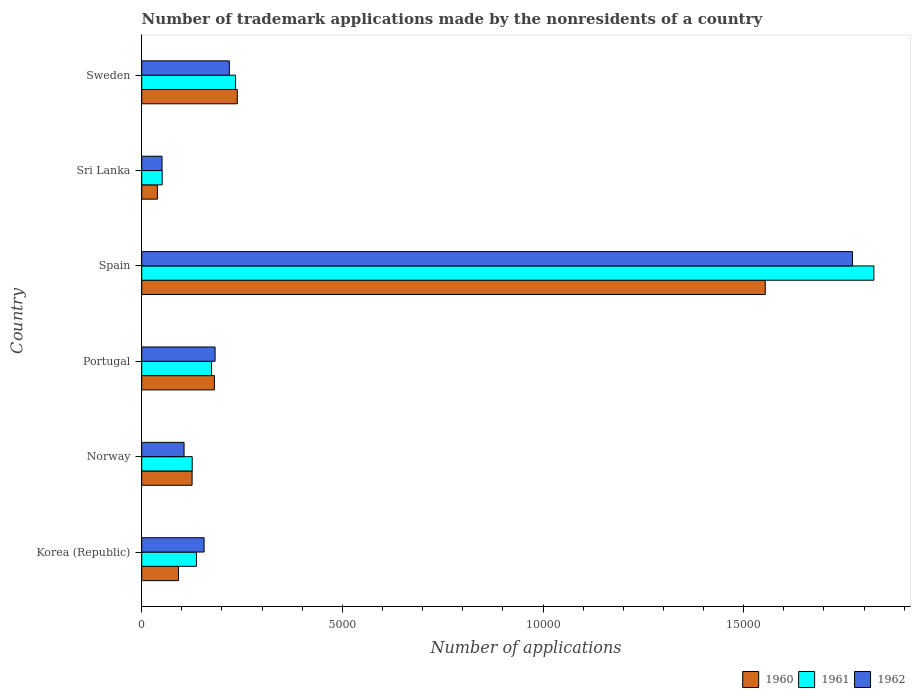How many different coloured bars are there?
Keep it short and to the point. 3. How many groups of bars are there?
Your response must be concise. 6. Are the number of bars per tick equal to the number of legend labels?
Provide a short and direct response. Yes. How many bars are there on the 6th tick from the top?
Keep it short and to the point. 3. How many bars are there on the 6th tick from the bottom?
Your answer should be compact. 3. What is the number of trademark applications made by the nonresidents in 1961 in Spain?
Your response must be concise. 1.82e+04. Across all countries, what is the maximum number of trademark applications made by the nonresidents in 1961?
Make the answer very short. 1.82e+04. Across all countries, what is the minimum number of trademark applications made by the nonresidents in 1960?
Your response must be concise. 391. In which country was the number of trademark applications made by the nonresidents in 1960 maximum?
Your answer should be compact. Spain. In which country was the number of trademark applications made by the nonresidents in 1960 minimum?
Make the answer very short. Sri Lanka. What is the total number of trademark applications made by the nonresidents in 1962 in the graph?
Your answer should be compact. 2.48e+04. What is the difference between the number of trademark applications made by the nonresidents in 1960 in Korea (Republic) and that in Spain?
Your response must be concise. -1.46e+04. What is the difference between the number of trademark applications made by the nonresidents in 1960 in Portugal and the number of trademark applications made by the nonresidents in 1961 in Sweden?
Your answer should be compact. -527. What is the average number of trademark applications made by the nonresidents in 1962 per country?
Offer a very short reply. 4139.33. What is the difference between the number of trademark applications made by the nonresidents in 1961 and number of trademark applications made by the nonresidents in 1962 in Spain?
Provide a succinct answer. 534. What is the ratio of the number of trademark applications made by the nonresidents in 1960 in Korea (Republic) to that in Sweden?
Provide a short and direct response. 0.38. Is the number of trademark applications made by the nonresidents in 1962 in Spain less than that in Sri Lanka?
Your answer should be compact. No. What is the difference between the highest and the second highest number of trademark applications made by the nonresidents in 1960?
Keep it short and to the point. 1.32e+04. What is the difference between the highest and the lowest number of trademark applications made by the nonresidents in 1960?
Give a very brief answer. 1.51e+04. What does the 2nd bar from the bottom in Spain represents?
Provide a succinct answer. 1961. Does the graph contain grids?
Offer a terse response. No. How are the legend labels stacked?
Your answer should be very brief. Horizontal. What is the title of the graph?
Provide a short and direct response. Number of trademark applications made by the nonresidents of a country. Does "2013" appear as one of the legend labels in the graph?
Keep it short and to the point. No. What is the label or title of the X-axis?
Provide a short and direct response. Number of applications. What is the label or title of the Y-axis?
Make the answer very short. Country. What is the Number of applications of 1960 in Korea (Republic)?
Give a very brief answer. 916. What is the Number of applications of 1961 in Korea (Republic)?
Your response must be concise. 1363. What is the Number of applications in 1962 in Korea (Republic)?
Your answer should be very brief. 1554. What is the Number of applications in 1960 in Norway?
Keep it short and to the point. 1255. What is the Number of applications of 1961 in Norway?
Make the answer very short. 1258. What is the Number of applications of 1962 in Norway?
Make the answer very short. 1055. What is the Number of applications of 1960 in Portugal?
Provide a short and direct response. 1811. What is the Number of applications of 1961 in Portugal?
Provide a short and direct response. 1740. What is the Number of applications of 1962 in Portugal?
Keep it short and to the point. 1828. What is the Number of applications in 1960 in Spain?
Make the answer very short. 1.55e+04. What is the Number of applications in 1961 in Spain?
Provide a succinct answer. 1.82e+04. What is the Number of applications in 1962 in Spain?
Your answer should be compact. 1.77e+04. What is the Number of applications in 1960 in Sri Lanka?
Provide a succinct answer. 391. What is the Number of applications in 1961 in Sri Lanka?
Keep it short and to the point. 510. What is the Number of applications of 1962 in Sri Lanka?
Give a very brief answer. 506. What is the Number of applications in 1960 in Sweden?
Give a very brief answer. 2381. What is the Number of applications in 1961 in Sweden?
Offer a very short reply. 2338. What is the Number of applications of 1962 in Sweden?
Give a very brief answer. 2183. Across all countries, what is the maximum Number of applications of 1960?
Ensure brevity in your answer.  1.55e+04. Across all countries, what is the maximum Number of applications in 1961?
Keep it short and to the point. 1.82e+04. Across all countries, what is the maximum Number of applications in 1962?
Give a very brief answer. 1.77e+04. Across all countries, what is the minimum Number of applications in 1960?
Your response must be concise. 391. Across all countries, what is the minimum Number of applications in 1961?
Offer a terse response. 510. Across all countries, what is the minimum Number of applications of 1962?
Give a very brief answer. 506. What is the total Number of applications in 1960 in the graph?
Your answer should be very brief. 2.23e+04. What is the total Number of applications in 1961 in the graph?
Your answer should be compact. 2.55e+04. What is the total Number of applications in 1962 in the graph?
Your answer should be compact. 2.48e+04. What is the difference between the Number of applications in 1960 in Korea (Republic) and that in Norway?
Provide a short and direct response. -339. What is the difference between the Number of applications of 1961 in Korea (Republic) and that in Norway?
Make the answer very short. 105. What is the difference between the Number of applications of 1962 in Korea (Republic) and that in Norway?
Keep it short and to the point. 499. What is the difference between the Number of applications of 1960 in Korea (Republic) and that in Portugal?
Your response must be concise. -895. What is the difference between the Number of applications in 1961 in Korea (Republic) and that in Portugal?
Your response must be concise. -377. What is the difference between the Number of applications of 1962 in Korea (Republic) and that in Portugal?
Your response must be concise. -274. What is the difference between the Number of applications in 1960 in Korea (Republic) and that in Spain?
Your response must be concise. -1.46e+04. What is the difference between the Number of applications of 1961 in Korea (Republic) and that in Spain?
Provide a succinct answer. -1.69e+04. What is the difference between the Number of applications in 1962 in Korea (Republic) and that in Spain?
Give a very brief answer. -1.62e+04. What is the difference between the Number of applications in 1960 in Korea (Republic) and that in Sri Lanka?
Make the answer very short. 525. What is the difference between the Number of applications of 1961 in Korea (Republic) and that in Sri Lanka?
Keep it short and to the point. 853. What is the difference between the Number of applications of 1962 in Korea (Republic) and that in Sri Lanka?
Your answer should be compact. 1048. What is the difference between the Number of applications in 1960 in Korea (Republic) and that in Sweden?
Offer a terse response. -1465. What is the difference between the Number of applications of 1961 in Korea (Republic) and that in Sweden?
Give a very brief answer. -975. What is the difference between the Number of applications of 1962 in Korea (Republic) and that in Sweden?
Your answer should be very brief. -629. What is the difference between the Number of applications in 1960 in Norway and that in Portugal?
Offer a terse response. -556. What is the difference between the Number of applications in 1961 in Norway and that in Portugal?
Offer a terse response. -482. What is the difference between the Number of applications of 1962 in Norway and that in Portugal?
Provide a short and direct response. -773. What is the difference between the Number of applications of 1960 in Norway and that in Spain?
Your response must be concise. -1.43e+04. What is the difference between the Number of applications of 1961 in Norway and that in Spain?
Your answer should be compact. -1.70e+04. What is the difference between the Number of applications of 1962 in Norway and that in Spain?
Keep it short and to the point. -1.67e+04. What is the difference between the Number of applications in 1960 in Norway and that in Sri Lanka?
Keep it short and to the point. 864. What is the difference between the Number of applications of 1961 in Norway and that in Sri Lanka?
Provide a short and direct response. 748. What is the difference between the Number of applications of 1962 in Norway and that in Sri Lanka?
Offer a very short reply. 549. What is the difference between the Number of applications of 1960 in Norway and that in Sweden?
Provide a short and direct response. -1126. What is the difference between the Number of applications in 1961 in Norway and that in Sweden?
Offer a very short reply. -1080. What is the difference between the Number of applications in 1962 in Norway and that in Sweden?
Provide a succinct answer. -1128. What is the difference between the Number of applications in 1960 in Portugal and that in Spain?
Provide a short and direct response. -1.37e+04. What is the difference between the Number of applications of 1961 in Portugal and that in Spain?
Keep it short and to the point. -1.65e+04. What is the difference between the Number of applications in 1962 in Portugal and that in Spain?
Provide a short and direct response. -1.59e+04. What is the difference between the Number of applications in 1960 in Portugal and that in Sri Lanka?
Your answer should be very brief. 1420. What is the difference between the Number of applications of 1961 in Portugal and that in Sri Lanka?
Make the answer very short. 1230. What is the difference between the Number of applications in 1962 in Portugal and that in Sri Lanka?
Make the answer very short. 1322. What is the difference between the Number of applications in 1960 in Portugal and that in Sweden?
Your response must be concise. -570. What is the difference between the Number of applications in 1961 in Portugal and that in Sweden?
Keep it short and to the point. -598. What is the difference between the Number of applications of 1962 in Portugal and that in Sweden?
Your response must be concise. -355. What is the difference between the Number of applications in 1960 in Spain and that in Sri Lanka?
Ensure brevity in your answer.  1.51e+04. What is the difference between the Number of applications of 1961 in Spain and that in Sri Lanka?
Your answer should be very brief. 1.77e+04. What is the difference between the Number of applications of 1962 in Spain and that in Sri Lanka?
Ensure brevity in your answer.  1.72e+04. What is the difference between the Number of applications in 1960 in Spain and that in Sweden?
Provide a short and direct response. 1.32e+04. What is the difference between the Number of applications in 1961 in Spain and that in Sweden?
Ensure brevity in your answer.  1.59e+04. What is the difference between the Number of applications in 1962 in Spain and that in Sweden?
Your response must be concise. 1.55e+04. What is the difference between the Number of applications of 1960 in Sri Lanka and that in Sweden?
Offer a terse response. -1990. What is the difference between the Number of applications in 1961 in Sri Lanka and that in Sweden?
Offer a very short reply. -1828. What is the difference between the Number of applications in 1962 in Sri Lanka and that in Sweden?
Make the answer very short. -1677. What is the difference between the Number of applications in 1960 in Korea (Republic) and the Number of applications in 1961 in Norway?
Keep it short and to the point. -342. What is the difference between the Number of applications in 1960 in Korea (Republic) and the Number of applications in 1962 in Norway?
Your response must be concise. -139. What is the difference between the Number of applications of 1961 in Korea (Republic) and the Number of applications of 1962 in Norway?
Your response must be concise. 308. What is the difference between the Number of applications in 1960 in Korea (Republic) and the Number of applications in 1961 in Portugal?
Keep it short and to the point. -824. What is the difference between the Number of applications of 1960 in Korea (Republic) and the Number of applications of 1962 in Portugal?
Give a very brief answer. -912. What is the difference between the Number of applications in 1961 in Korea (Republic) and the Number of applications in 1962 in Portugal?
Offer a very short reply. -465. What is the difference between the Number of applications of 1960 in Korea (Republic) and the Number of applications of 1961 in Spain?
Offer a very short reply. -1.73e+04. What is the difference between the Number of applications in 1960 in Korea (Republic) and the Number of applications in 1962 in Spain?
Your response must be concise. -1.68e+04. What is the difference between the Number of applications of 1961 in Korea (Republic) and the Number of applications of 1962 in Spain?
Your response must be concise. -1.63e+04. What is the difference between the Number of applications of 1960 in Korea (Republic) and the Number of applications of 1961 in Sri Lanka?
Make the answer very short. 406. What is the difference between the Number of applications of 1960 in Korea (Republic) and the Number of applications of 1962 in Sri Lanka?
Provide a short and direct response. 410. What is the difference between the Number of applications of 1961 in Korea (Republic) and the Number of applications of 1962 in Sri Lanka?
Keep it short and to the point. 857. What is the difference between the Number of applications in 1960 in Korea (Republic) and the Number of applications in 1961 in Sweden?
Provide a short and direct response. -1422. What is the difference between the Number of applications in 1960 in Korea (Republic) and the Number of applications in 1962 in Sweden?
Ensure brevity in your answer.  -1267. What is the difference between the Number of applications of 1961 in Korea (Republic) and the Number of applications of 1962 in Sweden?
Your response must be concise. -820. What is the difference between the Number of applications of 1960 in Norway and the Number of applications of 1961 in Portugal?
Offer a terse response. -485. What is the difference between the Number of applications of 1960 in Norway and the Number of applications of 1962 in Portugal?
Your answer should be very brief. -573. What is the difference between the Number of applications of 1961 in Norway and the Number of applications of 1962 in Portugal?
Provide a short and direct response. -570. What is the difference between the Number of applications of 1960 in Norway and the Number of applications of 1961 in Spain?
Provide a succinct answer. -1.70e+04. What is the difference between the Number of applications in 1960 in Norway and the Number of applications in 1962 in Spain?
Your answer should be compact. -1.65e+04. What is the difference between the Number of applications in 1961 in Norway and the Number of applications in 1962 in Spain?
Ensure brevity in your answer.  -1.65e+04. What is the difference between the Number of applications in 1960 in Norway and the Number of applications in 1961 in Sri Lanka?
Make the answer very short. 745. What is the difference between the Number of applications in 1960 in Norway and the Number of applications in 1962 in Sri Lanka?
Your answer should be very brief. 749. What is the difference between the Number of applications in 1961 in Norway and the Number of applications in 1962 in Sri Lanka?
Your answer should be compact. 752. What is the difference between the Number of applications in 1960 in Norway and the Number of applications in 1961 in Sweden?
Provide a short and direct response. -1083. What is the difference between the Number of applications of 1960 in Norway and the Number of applications of 1962 in Sweden?
Your response must be concise. -928. What is the difference between the Number of applications in 1961 in Norway and the Number of applications in 1962 in Sweden?
Your response must be concise. -925. What is the difference between the Number of applications in 1960 in Portugal and the Number of applications in 1961 in Spain?
Provide a succinct answer. -1.64e+04. What is the difference between the Number of applications of 1960 in Portugal and the Number of applications of 1962 in Spain?
Give a very brief answer. -1.59e+04. What is the difference between the Number of applications of 1961 in Portugal and the Number of applications of 1962 in Spain?
Offer a terse response. -1.60e+04. What is the difference between the Number of applications in 1960 in Portugal and the Number of applications in 1961 in Sri Lanka?
Ensure brevity in your answer.  1301. What is the difference between the Number of applications in 1960 in Portugal and the Number of applications in 1962 in Sri Lanka?
Provide a succinct answer. 1305. What is the difference between the Number of applications of 1961 in Portugal and the Number of applications of 1962 in Sri Lanka?
Ensure brevity in your answer.  1234. What is the difference between the Number of applications of 1960 in Portugal and the Number of applications of 1961 in Sweden?
Offer a terse response. -527. What is the difference between the Number of applications of 1960 in Portugal and the Number of applications of 1962 in Sweden?
Provide a succinct answer. -372. What is the difference between the Number of applications of 1961 in Portugal and the Number of applications of 1962 in Sweden?
Your response must be concise. -443. What is the difference between the Number of applications in 1960 in Spain and the Number of applications in 1961 in Sri Lanka?
Your answer should be compact. 1.50e+04. What is the difference between the Number of applications of 1960 in Spain and the Number of applications of 1962 in Sri Lanka?
Ensure brevity in your answer.  1.50e+04. What is the difference between the Number of applications of 1961 in Spain and the Number of applications of 1962 in Sri Lanka?
Give a very brief answer. 1.77e+04. What is the difference between the Number of applications of 1960 in Spain and the Number of applications of 1961 in Sweden?
Offer a terse response. 1.32e+04. What is the difference between the Number of applications in 1960 in Spain and the Number of applications in 1962 in Sweden?
Your answer should be very brief. 1.34e+04. What is the difference between the Number of applications in 1961 in Spain and the Number of applications in 1962 in Sweden?
Offer a terse response. 1.61e+04. What is the difference between the Number of applications in 1960 in Sri Lanka and the Number of applications in 1961 in Sweden?
Your response must be concise. -1947. What is the difference between the Number of applications of 1960 in Sri Lanka and the Number of applications of 1962 in Sweden?
Your response must be concise. -1792. What is the difference between the Number of applications of 1961 in Sri Lanka and the Number of applications of 1962 in Sweden?
Offer a terse response. -1673. What is the average Number of applications of 1960 per country?
Ensure brevity in your answer.  3715.17. What is the average Number of applications in 1961 per country?
Give a very brief answer. 4242.17. What is the average Number of applications in 1962 per country?
Offer a terse response. 4139.33. What is the difference between the Number of applications in 1960 and Number of applications in 1961 in Korea (Republic)?
Offer a terse response. -447. What is the difference between the Number of applications in 1960 and Number of applications in 1962 in Korea (Republic)?
Provide a short and direct response. -638. What is the difference between the Number of applications of 1961 and Number of applications of 1962 in Korea (Republic)?
Your answer should be compact. -191. What is the difference between the Number of applications of 1960 and Number of applications of 1961 in Norway?
Your response must be concise. -3. What is the difference between the Number of applications in 1960 and Number of applications in 1962 in Norway?
Provide a short and direct response. 200. What is the difference between the Number of applications in 1961 and Number of applications in 1962 in Norway?
Offer a very short reply. 203. What is the difference between the Number of applications in 1960 and Number of applications in 1961 in Portugal?
Your answer should be compact. 71. What is the difference between the Number of applications of 1960 and Number of applications of 1962 in Portugal?
Offer a terse response. -17. What is the difference between the Number of applications in 1961 and Number of applications in 1962 in Portugal?
Your answer should be compact. -88. What is the difference between the Number of applications in 1960 and Number of applications in 1961 in Spain?
Ensure brevity in your answer.  -2707. What is the difference between the Number of applications of 1960 and Number of applications of 1962 in Spain?
Give a very brief answer. -2173. What is the difference between the Number of applications in 1961 and Number of applications in 1962 in Spain?
Keep it short and to the point. 534. What is the difference between the Number of applications of 1960 and Number of applications of 1961 in Sri Lanka?
Provide a succinct answer. -119. What is the difference between the Number of applications of 1960 and Number of applications of 1962 in Sri Lanka?
Offer a terse response. -115. What is the difference between the Number of applications of 1961 and Number of applications of 1962 in Sri Lanka?
Your response must be concise. 4. What is the difference between the Number of applications of 1960 and Number of applications of 1961 in Sweden?
Provide a short and direct response. 43. What is the difference between the Number of applications in 1960 and Number of applications in 1962 in Sweden?
Your answer should be very brief. 198. What is the difference between the Number of applications in 1961 and Number of applications in 1962 in Sweden?
Keep it short and to the point. 155. What is the ratio of the Number of applications in 1960 in Korea (Republic) to that in Norway?
Make the answer very short. 0.73. What is the ratio of the Number of applications in 1961 in Korea (Republic) to that in Norway?
Give a very brief answer. 1.08. What is the ratio of the Number of applications of 1962 in Korea (Republic) to that in Norway?
Make the answer very short. 1.47. What is the ratio of the Number of applications of 1960 in Korea (Republic) to that in Portugal?
Give a very brief answer. 0.51. What is the ratio of the Number of applications in 1961 in Korea (Republic) to that in Portugal?
Offer a very short reply. 0.78. What is the ratio of the Number of applications in 1962 in Korea (Republic) to that in Portugal?
Your response must be concise. 0.85. What is the ratio of the Number of applications in 1960 in Korea (Republic) to that in Spain?
Provide a succinct answer. 0.06. What is the ratio of the Number of applications of 1961 in Korea (Republic) to that in Spain?
Keep it short and to the point. 0.07. What is the ratio of the Number of applications of 1962 in Korea (Republic) to that in Spain?
Ensure brevity in your answer.  0.09. What is the ratio of the Number of applications of 1960 in Korea (Republic) to that in Sri Lanka?
Keep it short and to the point. 2.34. What is the ratio of the Number of applications in 1961 in Korea (Republic) to that in Sri Lanka?
Your response must be concise. 2.67. What is the ratio of the Number of applications of 1962 in Korea (Republic) to that in Sri Lanka?
Keep it short and to the point. 3.07. What is the ratio of the Number of applications of 1960 in Korea (Republic) to that in Sweden?
Your answer should be compact. 0.38. What is the ratio of the Number of applications in 1961 in Korea (Republic) to that in Sweden?
Your response must be concise. 0.58. What is the ratio of the Number of applications of 1962 in Korea (Republic) to that in Sweden?
Make the answer very short. 0.71. What is the ratio of the Number of applications in 1960 in Norway to that in Portugal?
Your answer should be very brief. 0.69. What is the ratio of the Number of applications of 1961 in Norway to that in Portugal?
Your answer should be very brief. 0.72. What is the ratio of the Number of applications in 1962 in Norway to that in Portugal?
Your answer should be very brief. 0.58. What is the ratio of the Number of applications in 1960 in Norway to that in Spain?
Keep it short and to the point. 0.08. What is the ratio of the Number of applications of 1961 in Norway to that in Spain?
Provide a succinct answer. 0.07. What is the ratio of the Number of applications in 1962 in Norway to that in Spain?
Your answer should be very brief. 0.06. What is the ratio of the Number of applications in 1960 in Norway to that in Sri Lanka?
Ensure brevity in your answer.  3.21. What is the ratio of the Number of applications of 1961 in Norway to that in Sri Lanka?
Provide a succinct answer. 2.47. What is the ratio of the Number of applications in 1962 in Norway to that in Sri Lanka?
Give a very brief answer. 2.08. What is the ratio of the Number of applications in 1960 in Norway to that in Sweden?
Give a very brief answer. 0.53. What is the ratio of the Number of applications in 1961 in Norway to that in Sweden?
Give a very brief answer. 0.54. What is the ratio of the Number of applications in 1962 in Norway to that in Sweden?
Provide a short and direct response. 0.48. What is the ratio of the Number of applications in 1960 in Portugal to that in Spain?
Your answer should be very brief. 0.12. What is the ratio of the Number of applications in 1961 in Portugal to that in Spain?
Your response must be concise. 0.1. What is the ratio of the Number of applications in 1962 in Portugal to that in Spain?
Your answer should be very brief. 0.1. What is the ratio of the Number of applications of 1960 in Portugal to that in Sri Lanka?
Provide a short and direct response. 4.63. What is the ratio of the Number of applications in 1961 in Portugal to that in Sri Lanka?
Your response must be concise. 3.41. What is the ratio of the Number of applications in 1962 in Portugal to that in Sri Lanka?
Your answer should be very brief. 3.61. What is the ratio of the Number of applications in 1960 in Portugal to that in Sweden?
Offer a very short reply. 0.76. What is the ratio of the Number of applications in 1961 in Portugal to that in Sweden?
Provide a succinct answer. 0.74. What is the ratio of the Number of applications in 1962 in Portugal to that in Sweden?
Provide a short and direct response. 0.84. What is the ratio of the Number of applications in 1960 in Spain to that in Sri Lanka?
Make the answer very short. 39.74. What is the ratio of the Number of applications of 1961 in Spain to that in Sri Lanka?
Offer a terse response. 35.77. What is the ratio of the Number of applications in 1960 in Spain to that in Sweden?
Offer a very short reply. 6.53. What is the ratio of the Number of applications of 1961 in Spain to that in Sweden?
Offer a very short reply. 7.8. What is the ratio of the Number of applications of 1962 in Spain to that in Sweden?
Give a very brief answer. 8.11. What is the ratio of the Number of applications of 1960 in Sri Lanka to that in Sweden?
Keep it short and to the point. 0.16. What is the ratio of the Number of applications in 1961 in Sri Lanka to that in Sweden?
Your answer should be very brief. 0.22. What is the ratio of the Number of applications in 1962 in Sri Lanka to that in Sweden?
Offer a very short reply. 0.23. What is the difference between the highest and the second highest Number of applications in 1960?
Offer a very short reply. 1.32e+04. What is the difference between the highest and the second highest Number of applications of 1961?
Your response must be concise. 1.59e+04. What is the difference between the highest and the second highest Number of applications in 1962?
Ensure brevity in your answer.  1.55e+04. What is the difference between the highest and the lowest Number of applications in 1960?
Offer a terse response. 1.51e+04. What is the difference between the highest and the lowest Number of applications in 1961?
Offer a terse response. 1.77e+04. What is the difference between the highest and the lowest Number of applications in 1962?
Your answer should be very brief. 1.72e+04. 